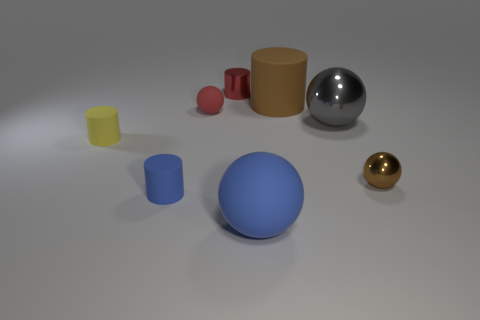Is the large cylinder the same color as the large matte sphere?
Provide a short and direct response. No. What is the material of the brown object that is right of the matte cylinder that is on the right side of the blue thing that is on the left side of the small shiny cylinder?
Provide a succinct answer. Metal. There is a big metal sphere; are there any shiny objects to the left of it?
Make the answer very short. Yes. There is a blue object that is the same size as the gray sphere; what is its shape?
Your answer should be very brief. Sphere. Does the yellow cylinder have the same material as the brown sphere?
Your response must be concise. No. How many matte things are either blue cylinders or brown cylinders?
Ensure brevity in your answer.  2. What is the shape of the object that is the same color as the large matte sphere?
Offer a terse response. Cylinder. There is a tiny matte object that is to the left of the small blue matte object; is it the same color as the tiny shiny ball?
Offer a very short reply. No. What shape is the large matte thing in front of the gray metallic ball that is behind the small yellow rubber cylinder?
Your answer should be very brief. Sphere. What number of things are either spheres right of the big matte sphere or things that are behind the small red matte sphere?
Provide a short and direct response. 4. 